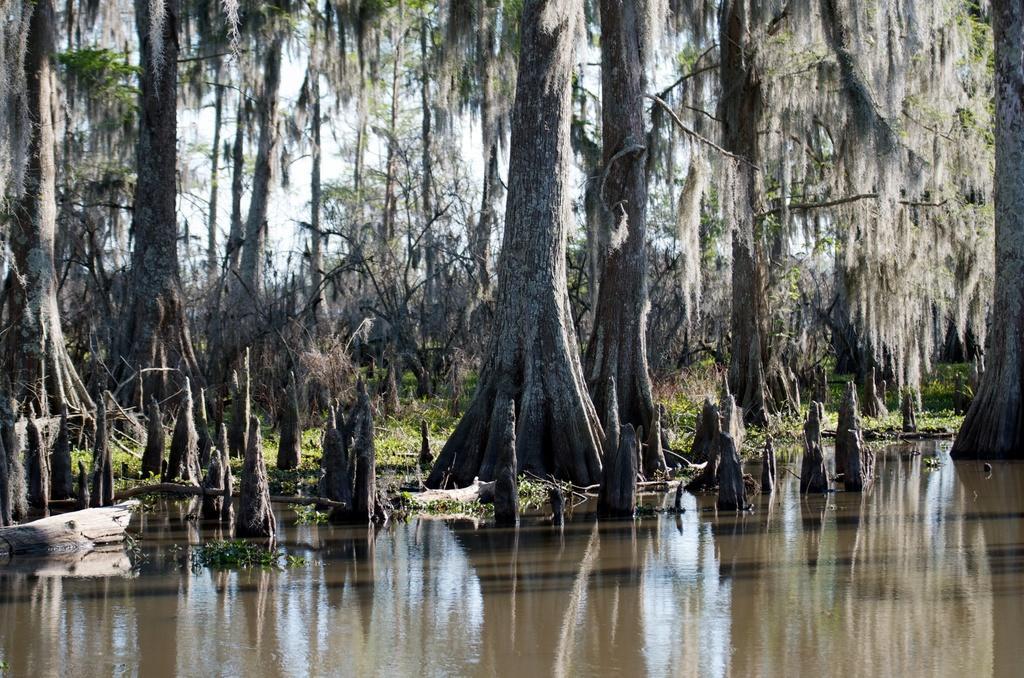How would you summarize this image in a sentence or two? In this picture we can observe water. There are some plants and trees. In the background there is a sky. 